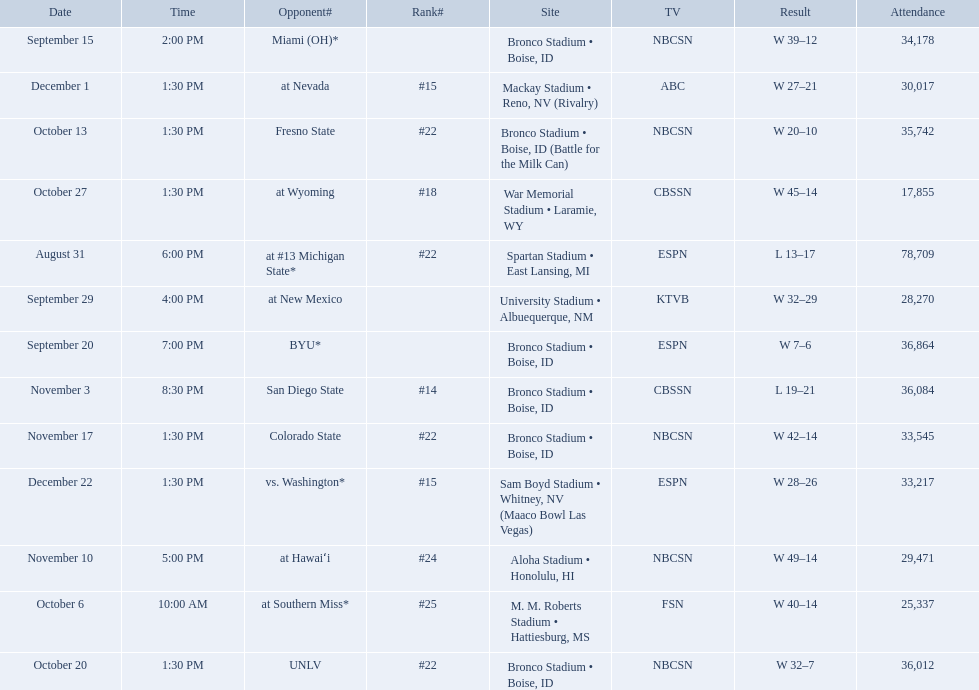Who were all the opponents for boise state? At #13 michigan state*, miami (oh)*, byu*, at new mexico, at southern miss*, fresno state, unlv, at wyoming, san diego state, at hawaiʻi, colorado state, at nevada, vs. washington*. Which opponents were ranked? At #13 michigan state*, #22, at southern miss*, #25, fresno state, #22, unlv, #22, at wyoming, #18, san diego state, #14. Which opponent had the highest rank? San Diego State. 